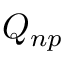<formula> <loc_0><loc_0><loc_500><loc_500>Q _ { n p }</formula> 